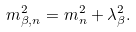Convert formula to latex. <formula><loc_0><loc_0><loc_500><loc_500>m _ { \beta , n } ^ { 2 } = m _ { n } ^ { 2 } + \lambda _ { \beta } ^ { 2 } .</formula> 